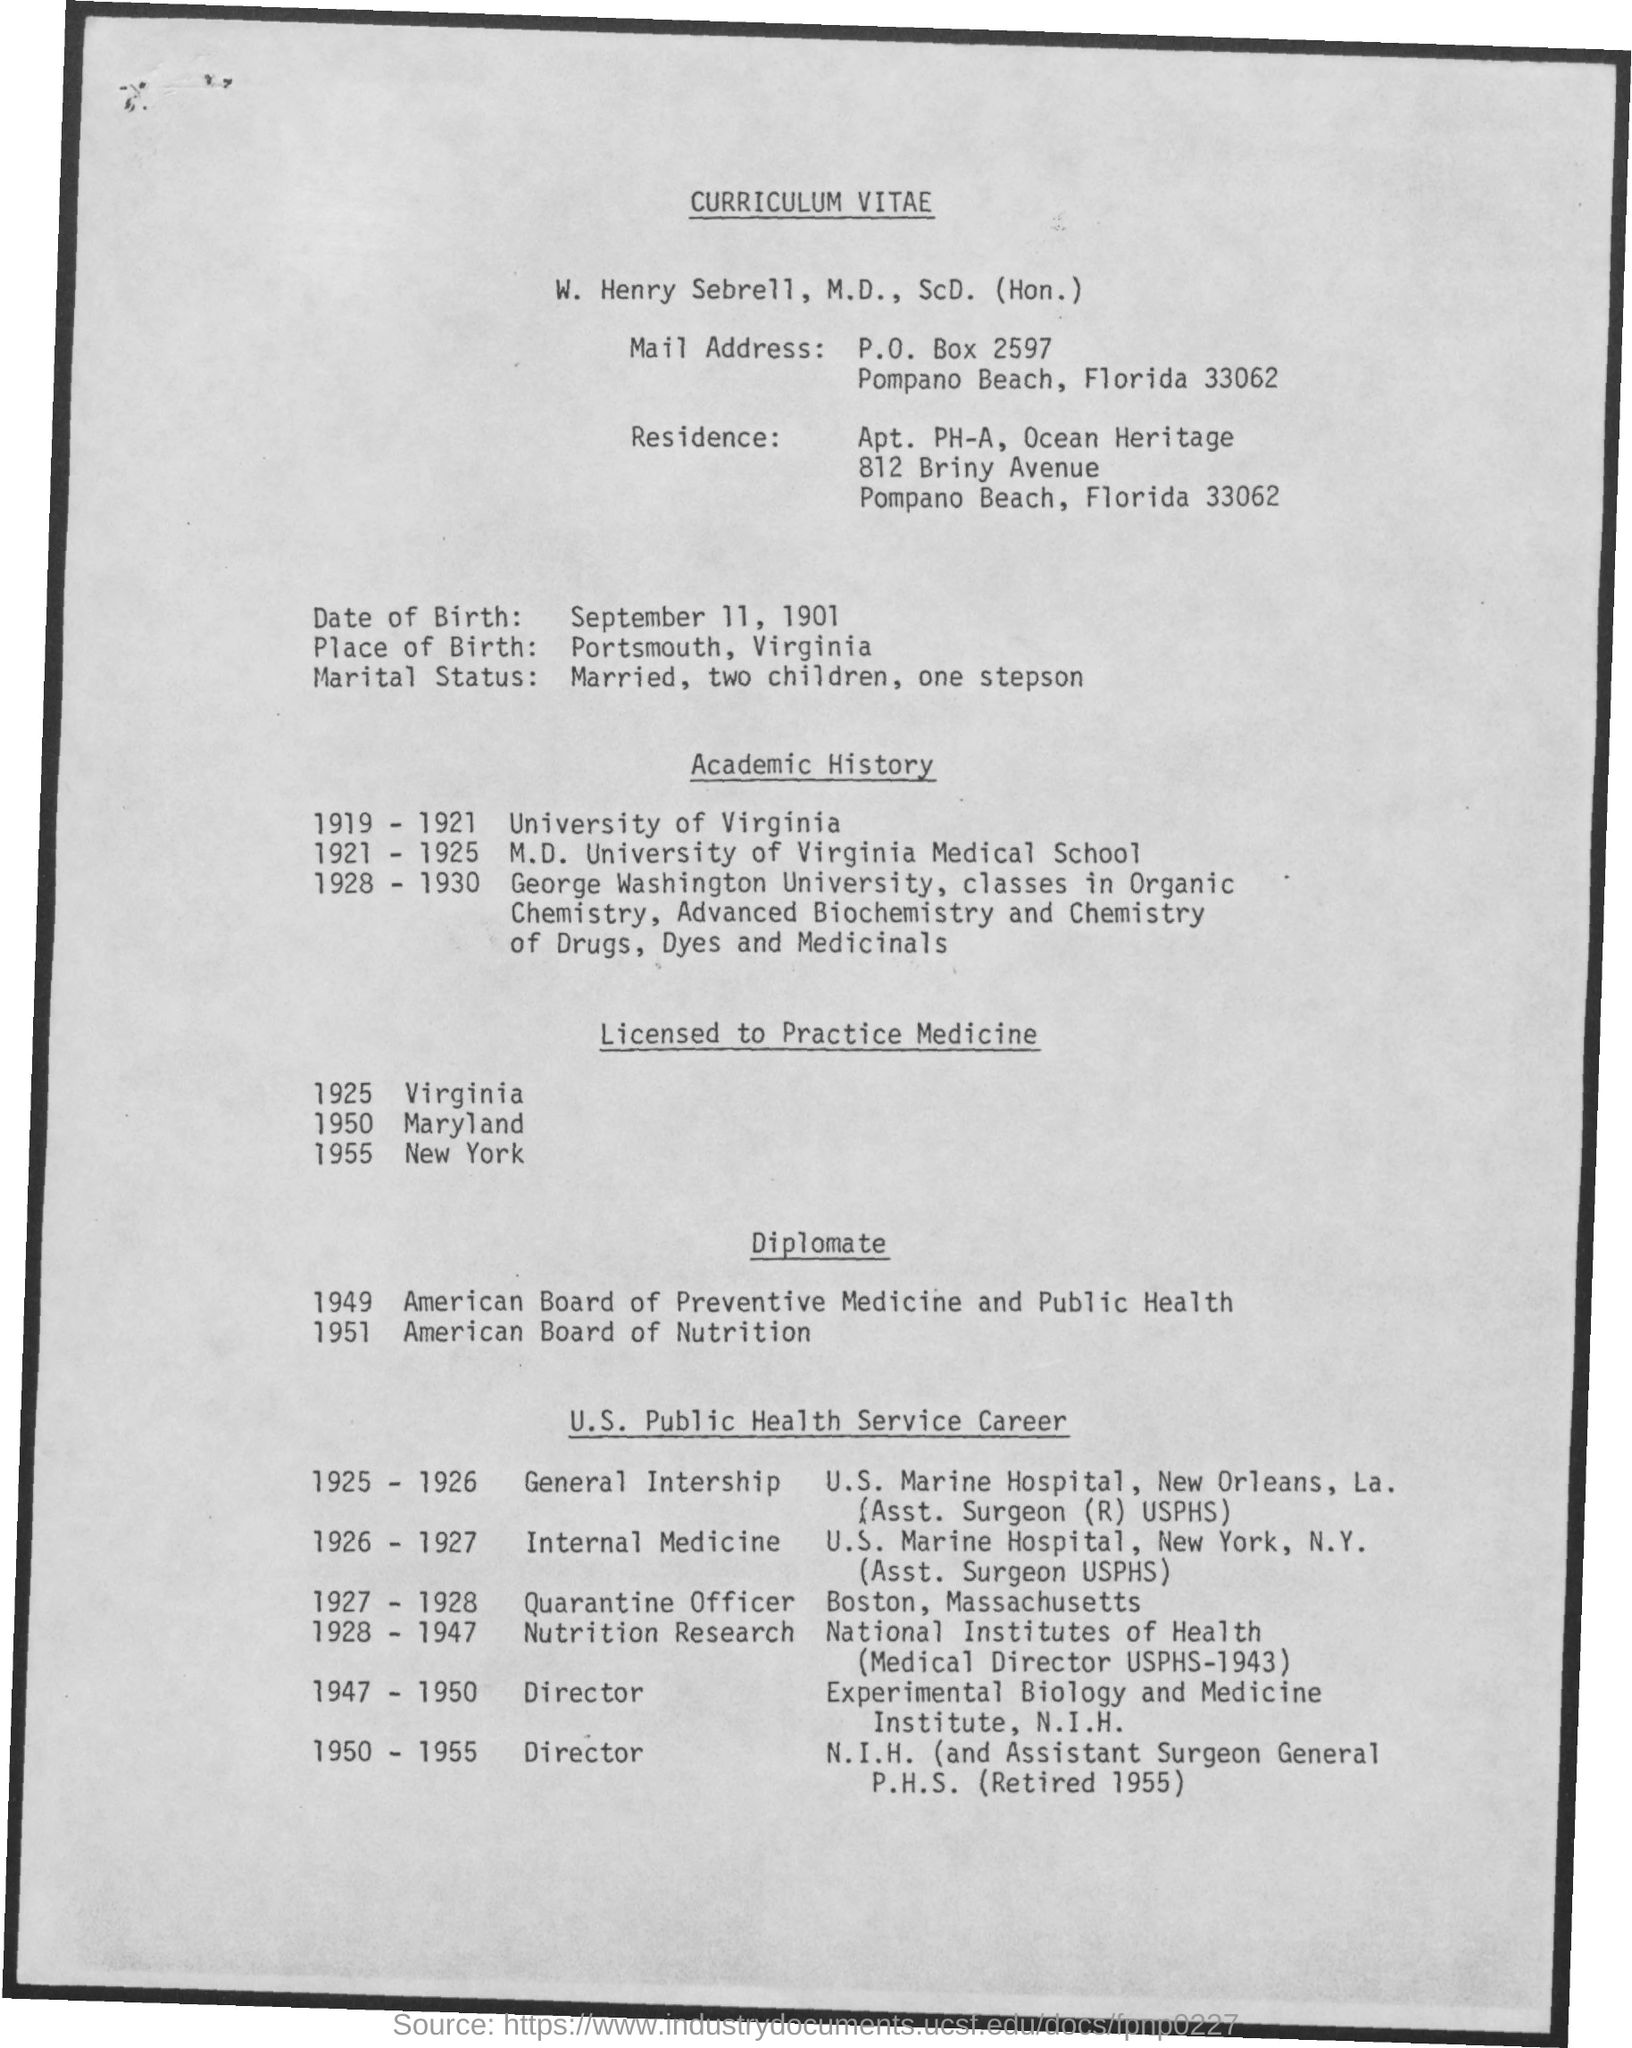Indicate a few pertinent items in this graphic. In 1925, he was licensed to practice law in the state of Virginia. When was the individual licensed to practice in Maryland? 1950. The place of birth of the individual is Portsmouth. Thomas Edison attended the University of Virginia from 1919 to 1921. He was licensed to practice in New York in 1955. 